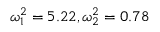<formula> <loc_0><loc_0><loc_500><loc_500>\omega _ { 1 } ^ { 2 } = 5 . 2 2 , \omega _ { 2 } ^ { 2 } = 0 . 7 8</formula> 